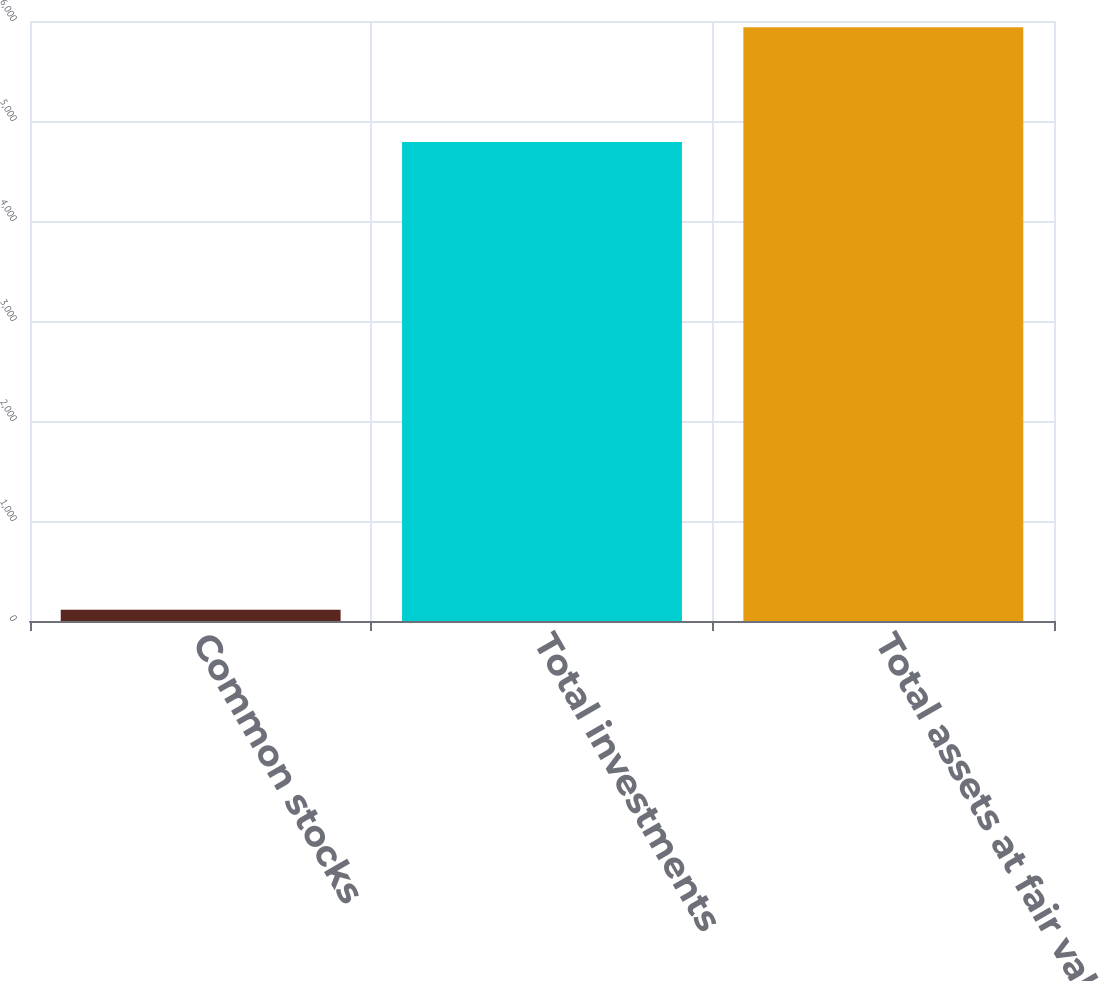Convert chart to OTSL. <chart><loc_0><loc_0><loc_500><loc_500><bar_chart><fcel>Common stocks<fcel>Total investments<fcel>Total assets at fair value<nl><fcel>113<fcel>4789<fcel>5938<nl></chart> 